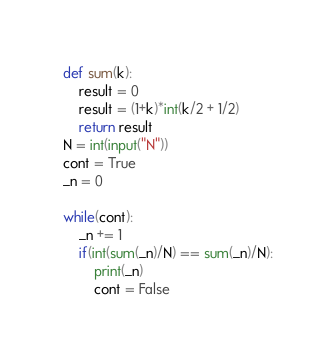Convert code to text. <code><loc_0><loc_0><loc_500><loc_500><_Python_>def sum(k):
    result = 0
    result = (1+k)*int(k/2 + 1/2)
    return result
N = int(input("N"))
cont = True
_n = 0

while(cont):
    _n += 1
    if(int(sum(_n)/N) == sum(_n)/N):
        print(_n)
        cont = False</code> 